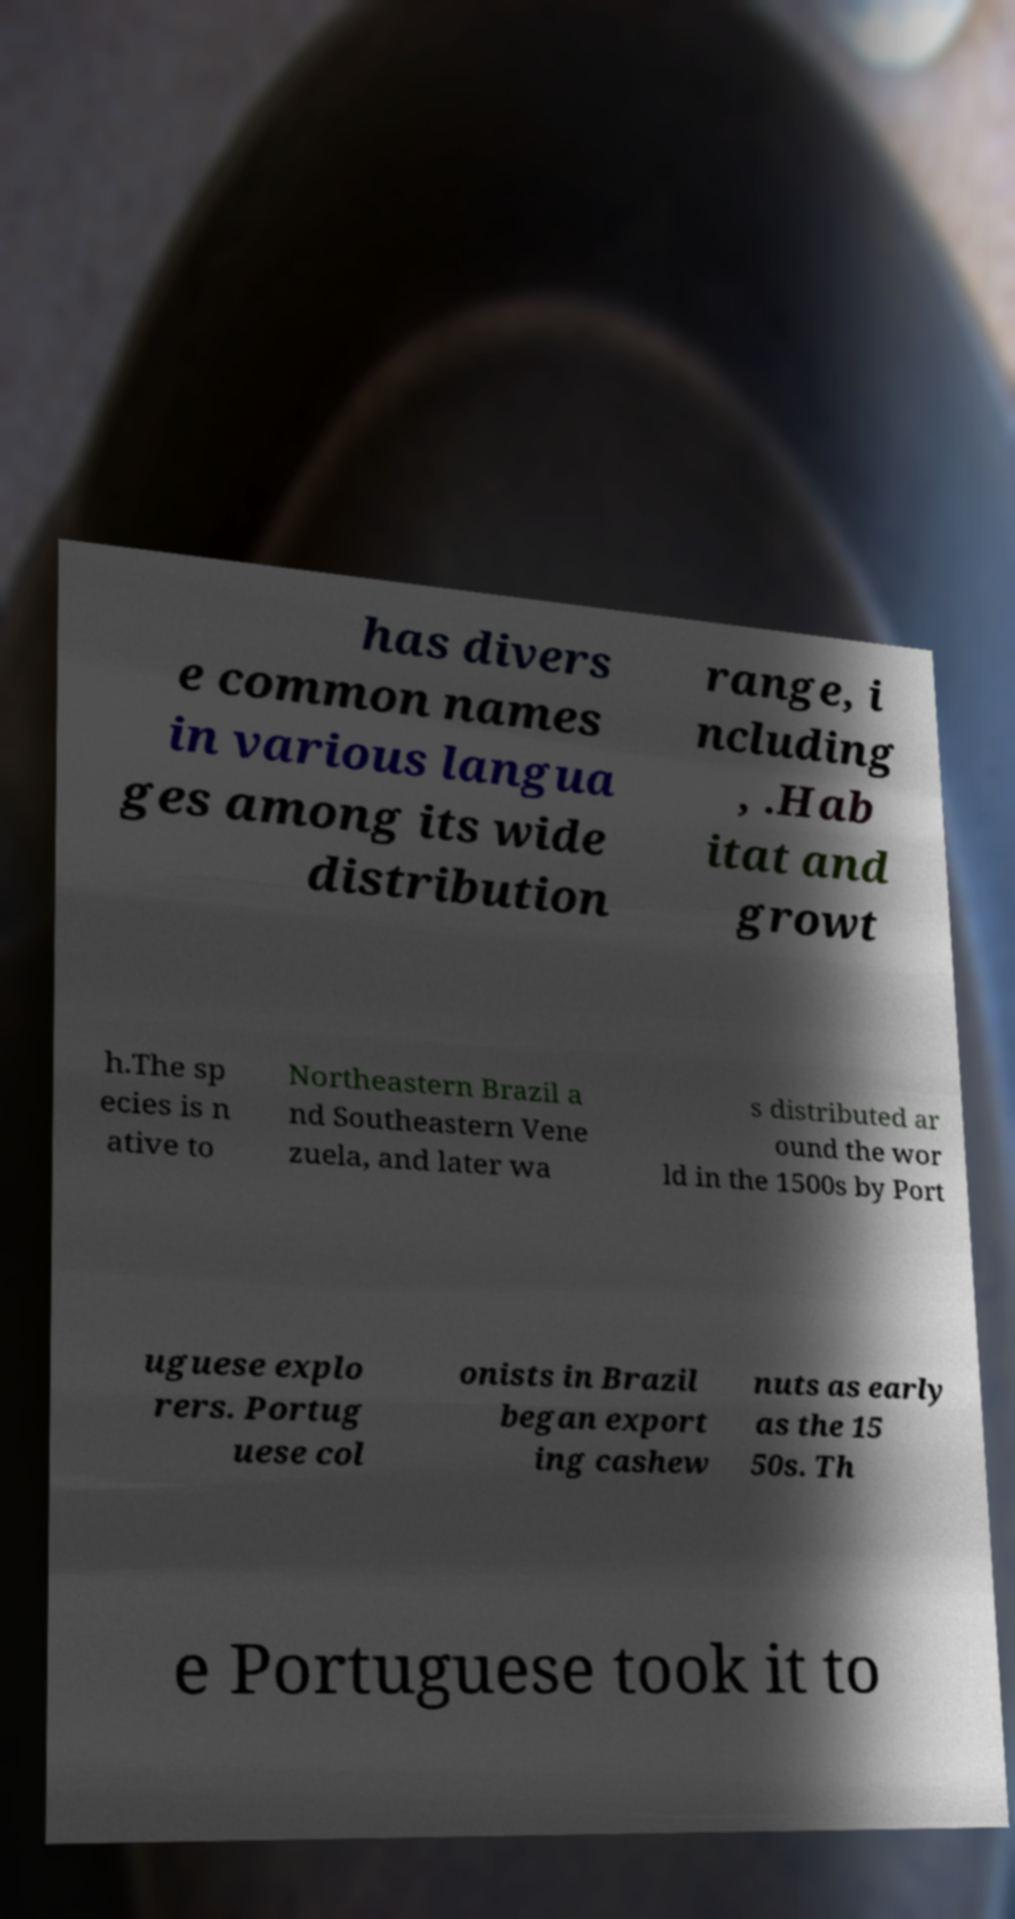What messages or text are displayed in this image? I need them in a readable, typed format. has divers e common names in various langua ges among its wide distribution range, i ncluding , .Hab itat and growt h.The sp ecies is n ative to Northeastern Brazil a nd Southeastern Vene zuela, and later wa s distributed ar ound the wor ld in the 1500s by Port uguese explo rers. Portug uese col onists in Brazil began export ing cashew nuts as early as the 15 50s. Th e Portuguese took it to 